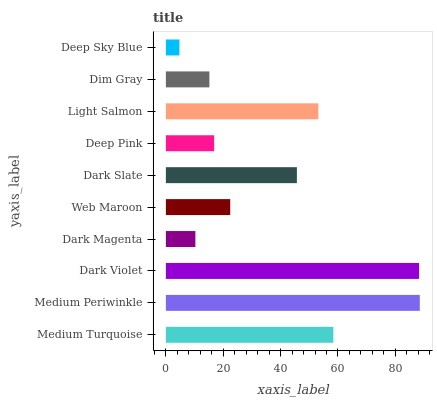Is Deep Sky Blue the minimum?
Answer yes or no. Yes. Is Medium Periwinkle the maximum?
Answer yes or no. Yes. Is Dark Violet the minimum?
Answer yes or no. No. Is Dark Violet the maximum?
Answer yes or no. No. Is Medium Periwinkle greater than Dark Violet?
Answer yes or no. Yes. Is Dark Violet less than Medium Periwinkle?
Answer yes or no. Yes. Is Dark Violet greater than Medium Periwinkle?
Answer yes or no. No. Is Medium Periwinkle less than Dark Violet?
Answer yes or no. No. Is Dark Slate the high median?
Answer yes or no. Yes. Is Web Maroon the low median?
Answer yes or no. Yes. Is Dark Violet the high median?
Answer yes or no. No. Is Deep Sky Blue the low median?
Answer yes or no. No. 